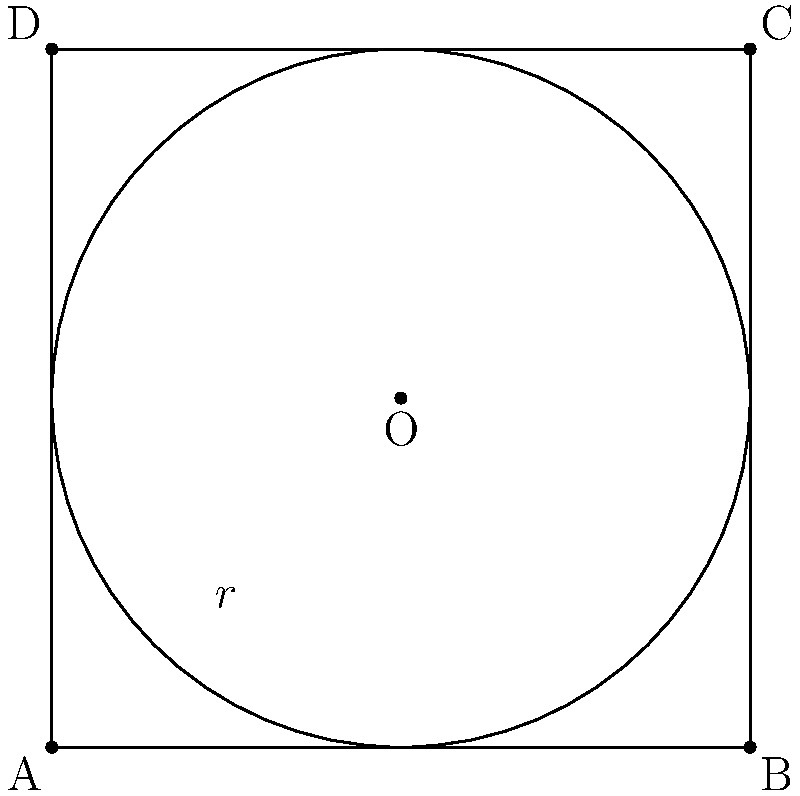You want to install a circular irrigation system in your square field. The field measures 4 units on each side, and the irrigation system can reach a maximum radius of 2 units. What percentage of the field will be irrigated by this system when placed at the center of the field? To solve this problem, we need to follow these steps:

1) The area of the square field:
   $A_{square} = 4 \times 4 = 16$ square units

2) The area of the circular irrigation system:
   $A_{circle} = \pi r^2 = \pi \times 2^2 = 4\pi$ square units

3) The percentage of the field irrigated:
   $\text{Percentage} = \frac{A_{circle}}{A_{square}} \times 100\%$

4) Substituting the values:
   $\text{Percentage} = \frac{4\pi}{16} \times 100\%$

5) Simplifying:
   $\text{Percentage} = \frac{\pi}{4} \times 100\% \approx 78.54\%$

Therefore, approximately 78.54% of the field will be irrigated by this system.
Answer: $78.54\%$ 